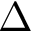Convert formula to latex. <formula><loc_0><loc_0><loc_500><loc_500>\Delta</formula> 